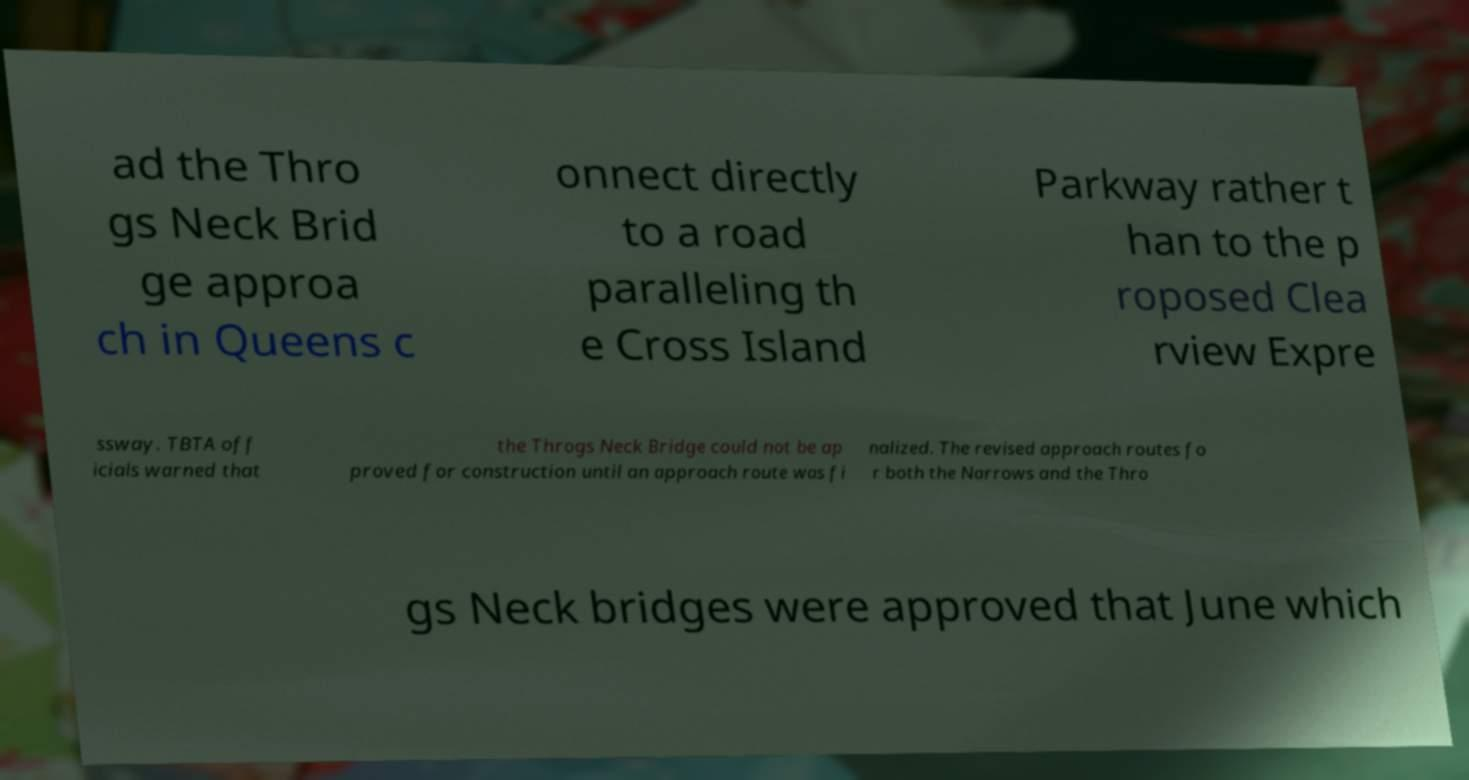Can you accurately transcribe the text from the provided image for me? ad the Thro gs Neck Brid ge approa ch in Queens c onnect directly to a road paralleling th e Cross Island Parkway rather t han to the p roposed Clea rview Expre ssway. TBTA off icials warned that the Throgs Neck Bridge could not be ap proved for construction until an approach route was fi nalized. The revised approach routes fo r both the Narrows and the Thro gs Neck bridges were approved that June which 